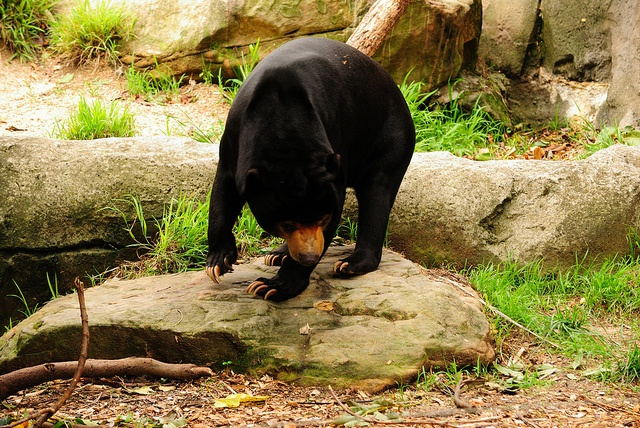Describe the objects in this image and their specific colors. I can see a bear in olive, black, maroon, and darkgray tones in this image. 